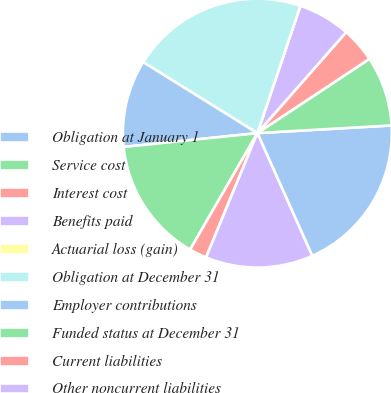Convert chart. <chart><loc_0><loc_0><loc_500><loc_500><pie_chart><fcel>Obligation at January 1<fcel>Service cost<fcel>Interest cost<fcel>Benefits paid<fcel>Actuarial loss (gain)<fcel>Obligation at December 31<fcel>Employer contributions<fcel>Funded status at December 31<fcel>Current liabilities<fcel>Other noncurrent liabilities<nl><fcel>19.22%<fcel>8.4%<fcel>4.2%<fcel>6.3%<fcel>0.0%<fcel>21.32%<fcel>10.5%<fcel>15.02%<fcel>2.1%<fcel>12.92%<nl></chart> 